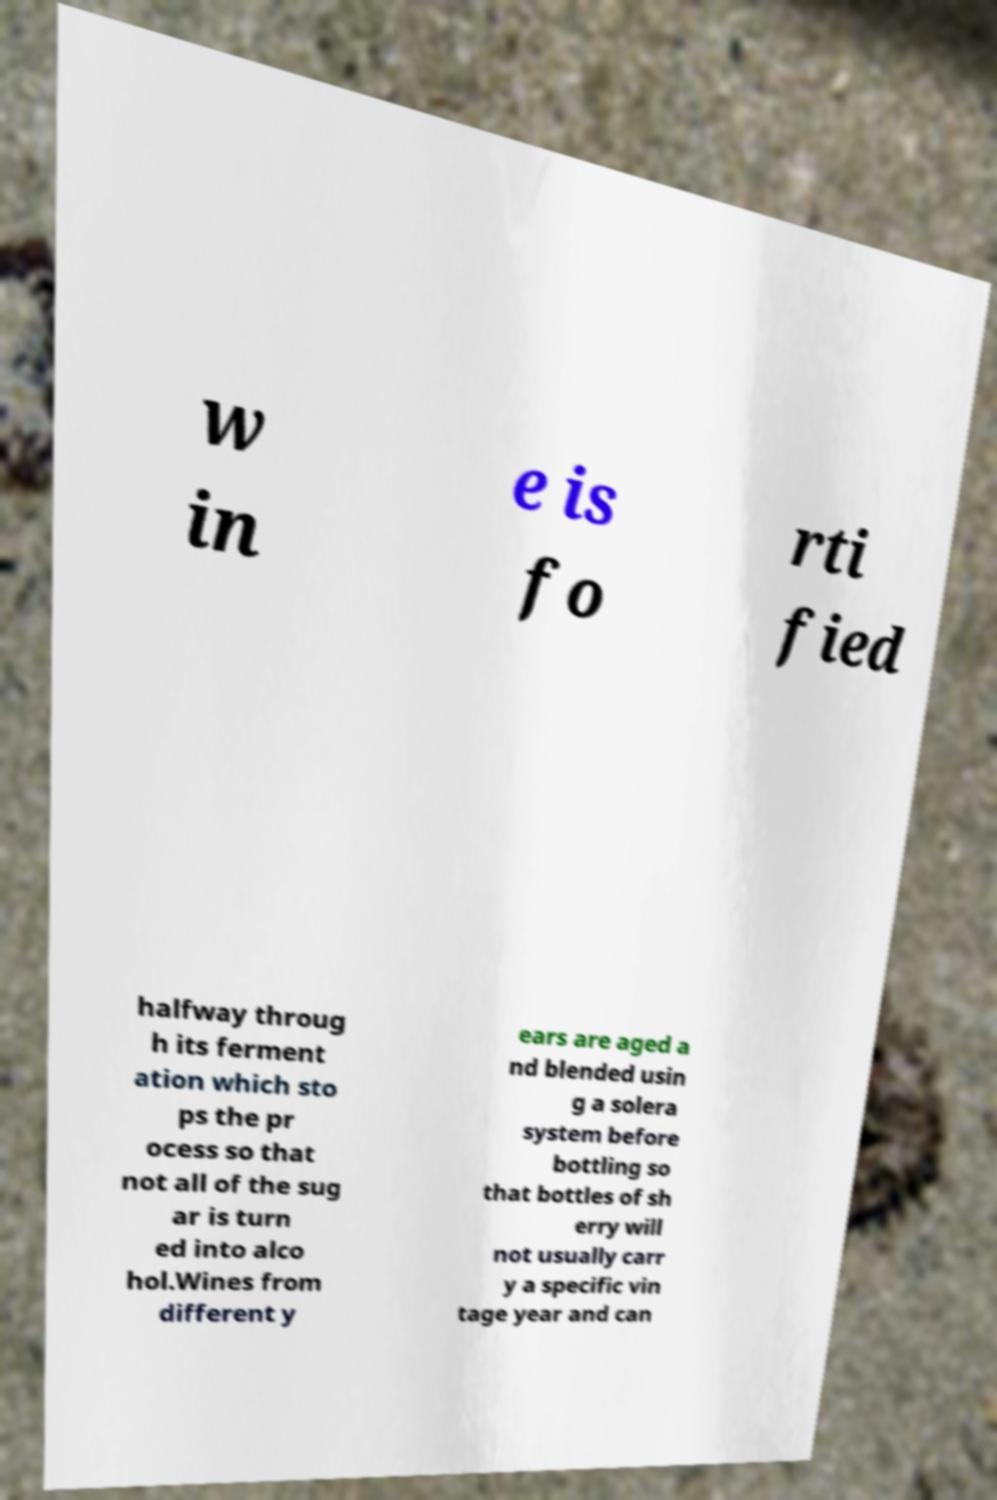For documentation purposes, I need the text within this image transcribed. Could you provide that? w in e is fo rti fied halfway throug h its ferment ation which sto ps the pr ocess so that not all of the sug ar is turn ed into alco hol.Wines from different y ears are aged a nd blended usin g a solera system before bottling so that bottles of sh erry will not usually carr y a specific vin tage year and can 